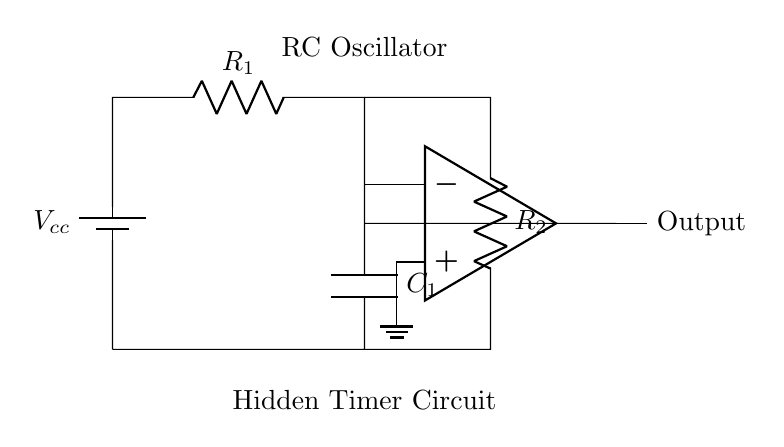What is the type of oscillator represented in this circuit? The circuit is identified as an RC oscillator, indicated by the presence of a resistor-capacitor pair used to generate an oscillating signal.
Answer: RC oscillator What is the purpose of capacitor C1 in this circuit? Capacitor C1 is used to store charge and determine the timing characteristics of the oscillator. Its charge and discharge cycle influences the oscillation frequency.
Answer: Timing What is the role of the op-amp in this circuit? The operational amplifier (op-amp) amplifies the voltage signal to produce a stable output for the oscillator. It is crucial for achieving the necessary gain to sustain oscillations.
Answer: Amplification How many resistors are present in the circuit? There are two resistors (R1 and R2) depicted in the circuit diagram. They form part of the voltage divider used in the timer circuit.
Answer: Two What connects the circuit to the ground? The op-amp's non-inverting terminal is connected to ground, indicating its role in stabilizing the circuit and providing a reference voltage for the amplification process.
Answer: Op-amp What components are responsible for generating oscillations in this circuit? The combination of resistors and capacitor (R1, R2, and C1) creates the RC timing network that is essential for generating the oscillations.
Answer: R1, R2, C1 